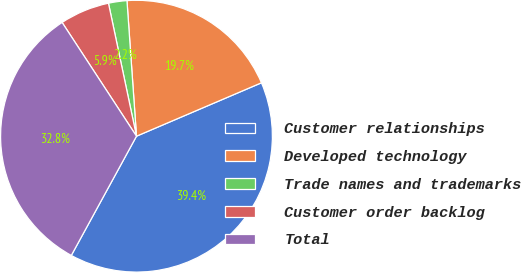Convert chart to OTSL. <chart><loc_0><loc_0><loc_500><loc_500><pie_chart><fcel>Customer relationships<fcel>Developed technology<fcel>Trade names and trademarks<fcel>Customer order backlog<fcel>Total<nl><fcel>39.39%<fcel>19.69%<fcel>2.19%<fcel>5.91%<fcel>32.82%<nl></chart> 